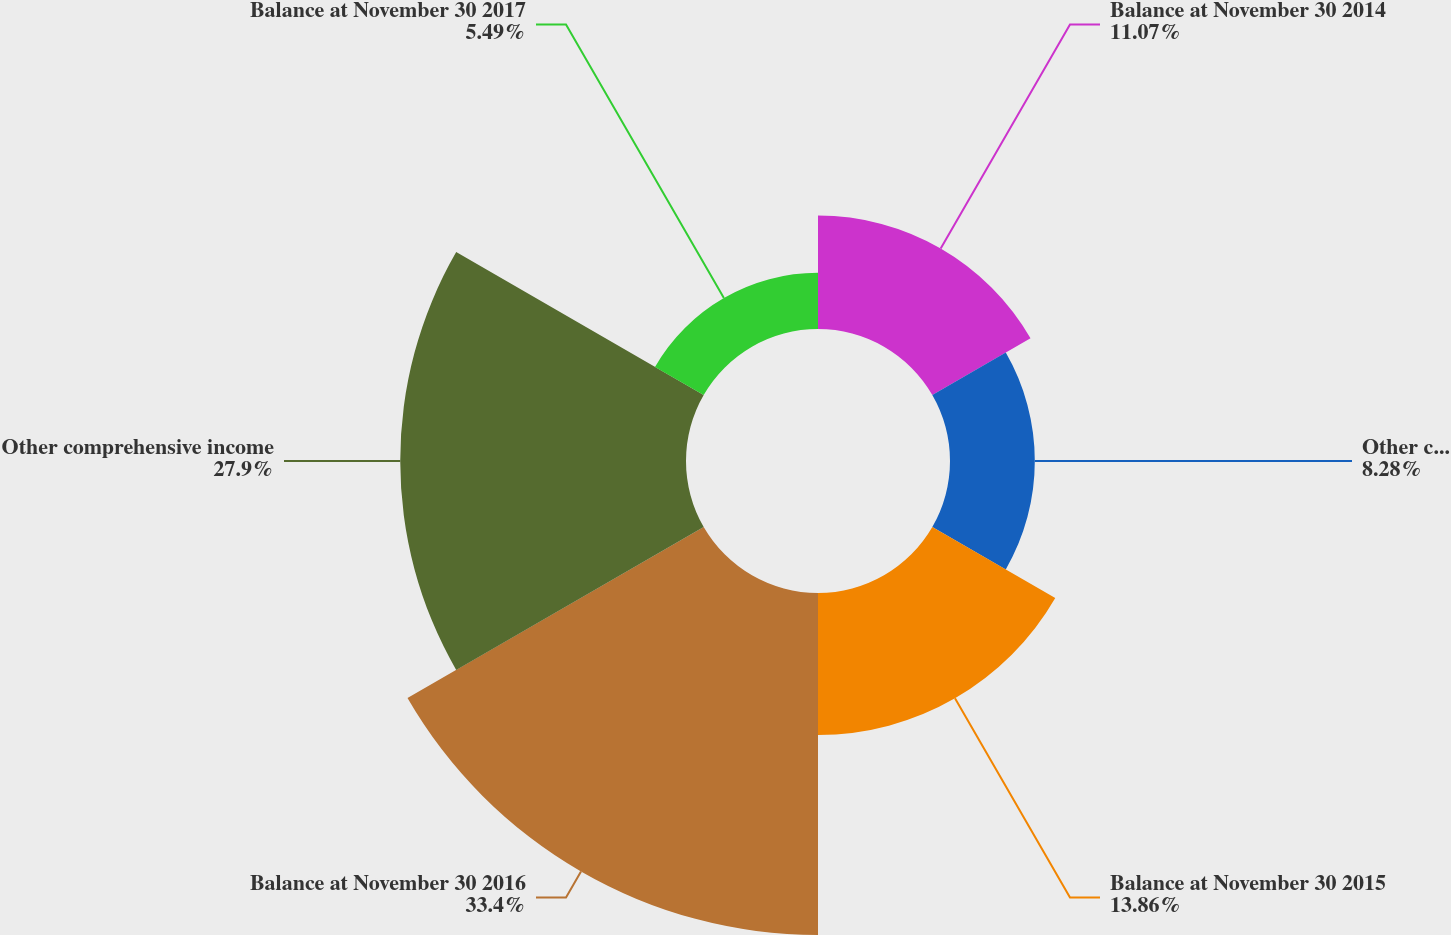<chart> <loc_0><loc_0><loc_500><loc_500><pie_chart><fcel>Balance at November 30 2014<fcel>Other comprehensive loss<fcel>Balance at November 30 2015<fcel>Balance at November 30 2016<fcel>Other comprehensive income<fcel>Balance at November 30 2017<nl><fcel>11.07%<fcel>8.28%<fcel>13.86%<fcel>33.39%<fcel>27.9%<fcel>5.49%<nl></chart> 